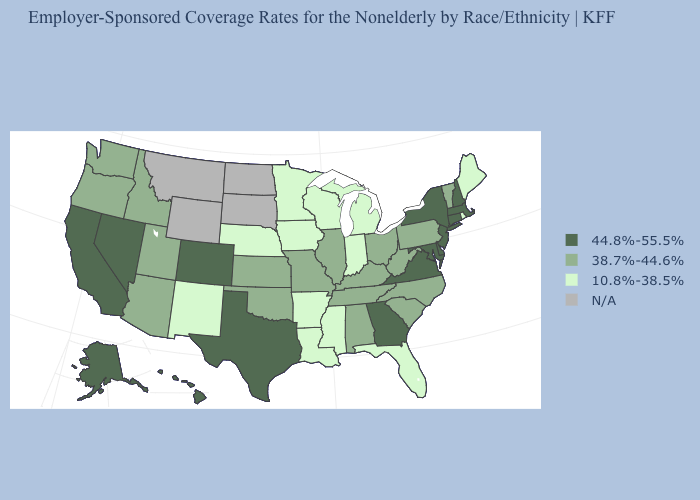What is the value of South Carolina?
Write a very short answer. 38.7%-44.6%. Does Nebraska have the lowest value in the MidWest?
Write a very short answer. Yes. Does the map have missing data?
Concise answer only. Yes. Name the states that have a value in the range N/A?
Write a very short answer. Montana, North Dakota, South Dakota, Wyoming. Does Florida have the lowest value in the South?
Be succinct. Yes. Which states have the lowest value in the MidWest?
Write a very short answer. Indiana, Iowa, Michigan, Minnesota, Nebraska, Wisconsin. Name the states that have a value in the range 10.8%-38.5%?
Answer briefly. Arkansas, Florida, Indiana, Iowa, Louisiana, Maine, Michigan, Minnesota, Mississippi, Nebraska, New Mexico, Rhode Island, Wisconsin. What is the highest value in states that border North Dakota?
Keep it brief. 10.8%-38.5%. Name the states that have a value in the range 38.7%-44.6%?
Short answer required. Alabama, Arizona, Idaho, Illinois, Kansas, Kentucky, Missouri, North Carolina, Ohio, Oklahoma, Oregon, Pennsylvania, South Carolina, Tennessee, Utah, Vermont, Washington, West Virginia. What is the value of Arizona?
Answer briefly. 38.7%-44.6%. Name the states that have a value in the range 44.8%-55.5%?
Answer briefly. Alaska, California, Colorado, Connecticut, Delaware, Georgia, Hawaii, Maryland, Massachusetts, Nevada, New Hampshire, New Jersey, New York, Texas, Virginia. Does West Virginia have the highest value in the South?
Answer briefly. No. Among the states that border Idaho , which have the highest value?
Be succinct. Nevada. What is the value of Vermont?
Write a very short answer. 38.7%-44.6%. 